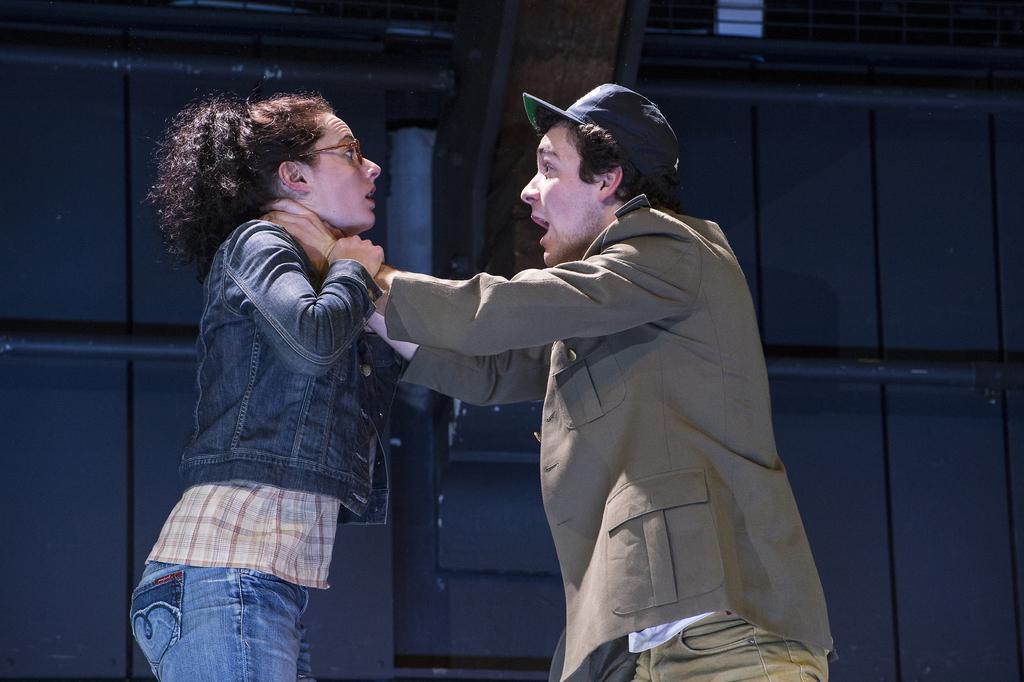Can you describe this image briefly? In the center of the image there are two people. In the background of the image there is a building. 